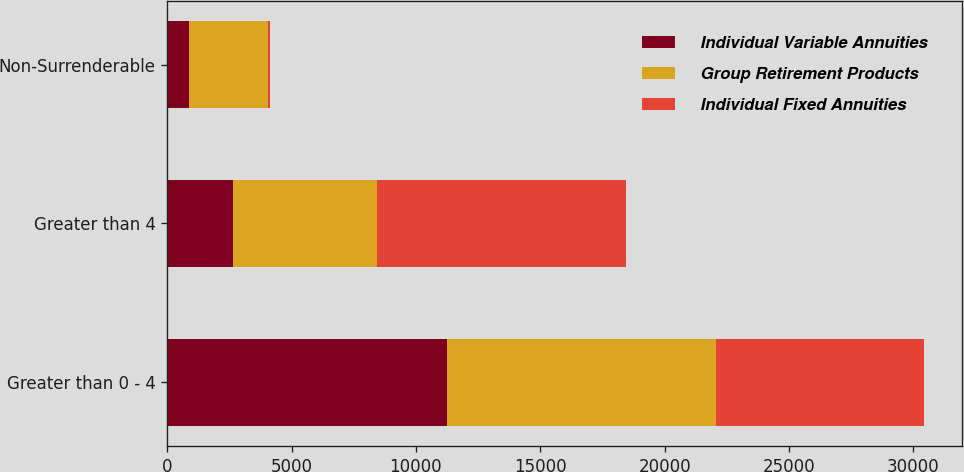Convert chart to OTSL. <chart><loc_0><loc_0><loc_500><loc_500><stacked_bar_chart><ecel><fcel>Greater than 0 - 4<fcel>Greater than 4<fcel>Non-Surrenderable<nl><fcel>Individual Variable Annuities<fcel>11248<fcel>2648<fcel>892<nl><fcel>Group Retirement Products<fcel>10815<fcel>5767<fcel>3148<nl><fcel>Individual Fixed Annuities<fcel>8386<fcel>10035<fcel>81<nl></chart> 